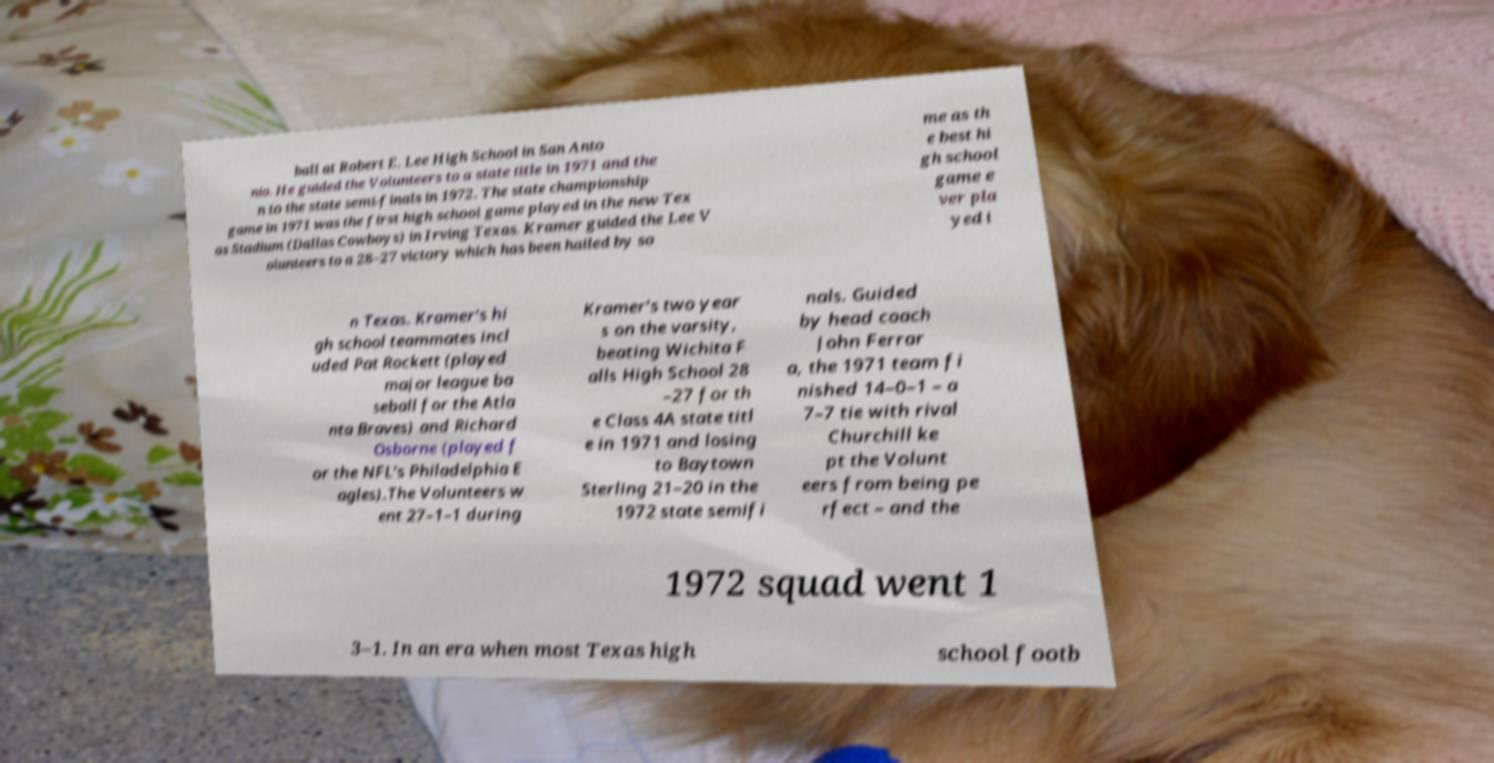Can you read and provide the text displayed in the image?This photo seems to have some interesting text. Can you extract and type it out for me? ball at Robert E. Lee High School in San Anto nio. He guided the Volunteers to a state title in 1971 and the n to the state semi-finals in 1972. The state championship game in 1971 was the first high school game played in the new Tex as Stadium (Dallas Cowboys) in Irving Texas. Kramer guided the Lee V olunteers to a 28–27 victory which has been hailed by so me as th e best hi gh school game e ver pla yed i n Texas. Kramer's hi gh school teammates incl uded Pat Rockett (played major league ba seball for the Atla nta Braves) and Richard Osborne (played f or the NFL's Philadelphia E agles).The Volunteers w ent 27–1–1 during Kramer's two year s on the varsity, beating Wichita F alls High School 28 –27 for th e Class 4A state titl e in 1971 and losing to Baytown Sterling 21–20 in the 1972 state semifi nals. Guided by head coach John Ferrar a, the 1971 team fi nished 14–0–1 – a 7–7 tie with rival Churchill ke pt the Volunt eers from being pe rfect – and the 1972 squad went 1 3–1. In an era when most Texas high school footb 